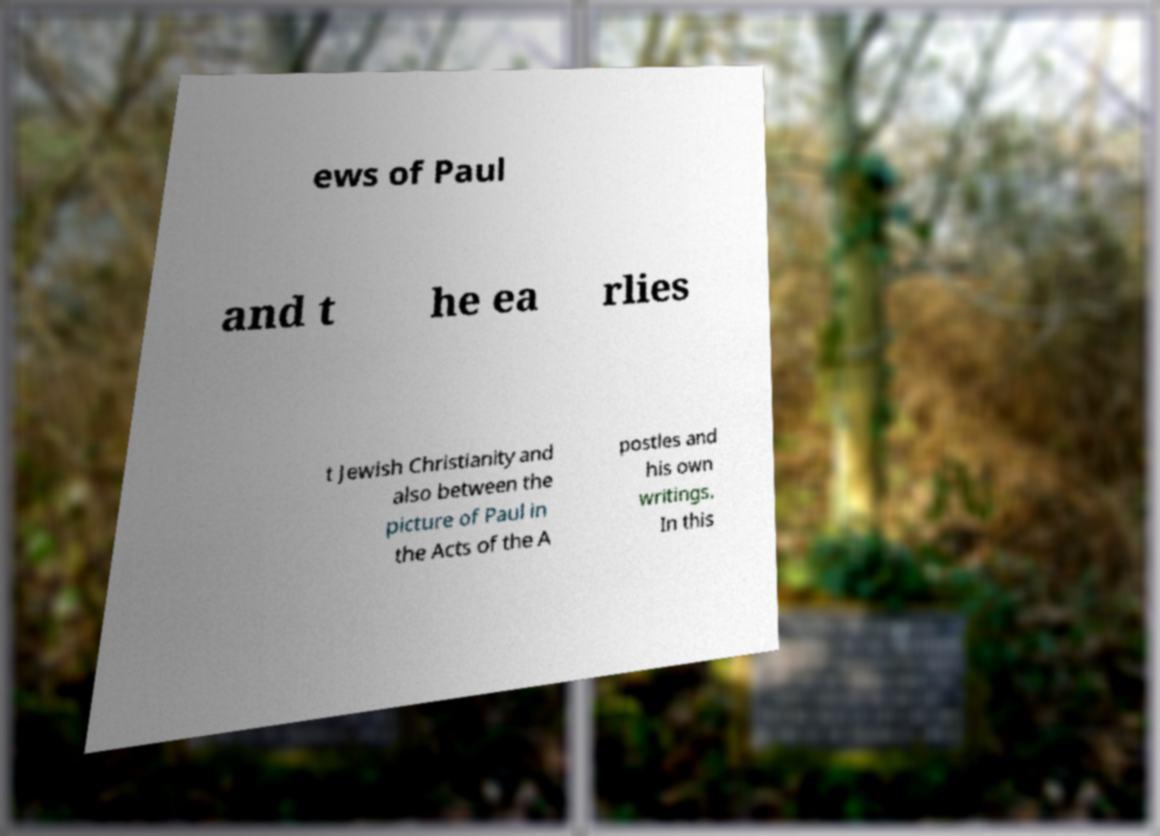Could you extract and type out the text from this image? ews of Paul and t he ea rlies t Jewish Christianity and also between the picture of Paul in the Acts of the A postles and his own writings. In this 